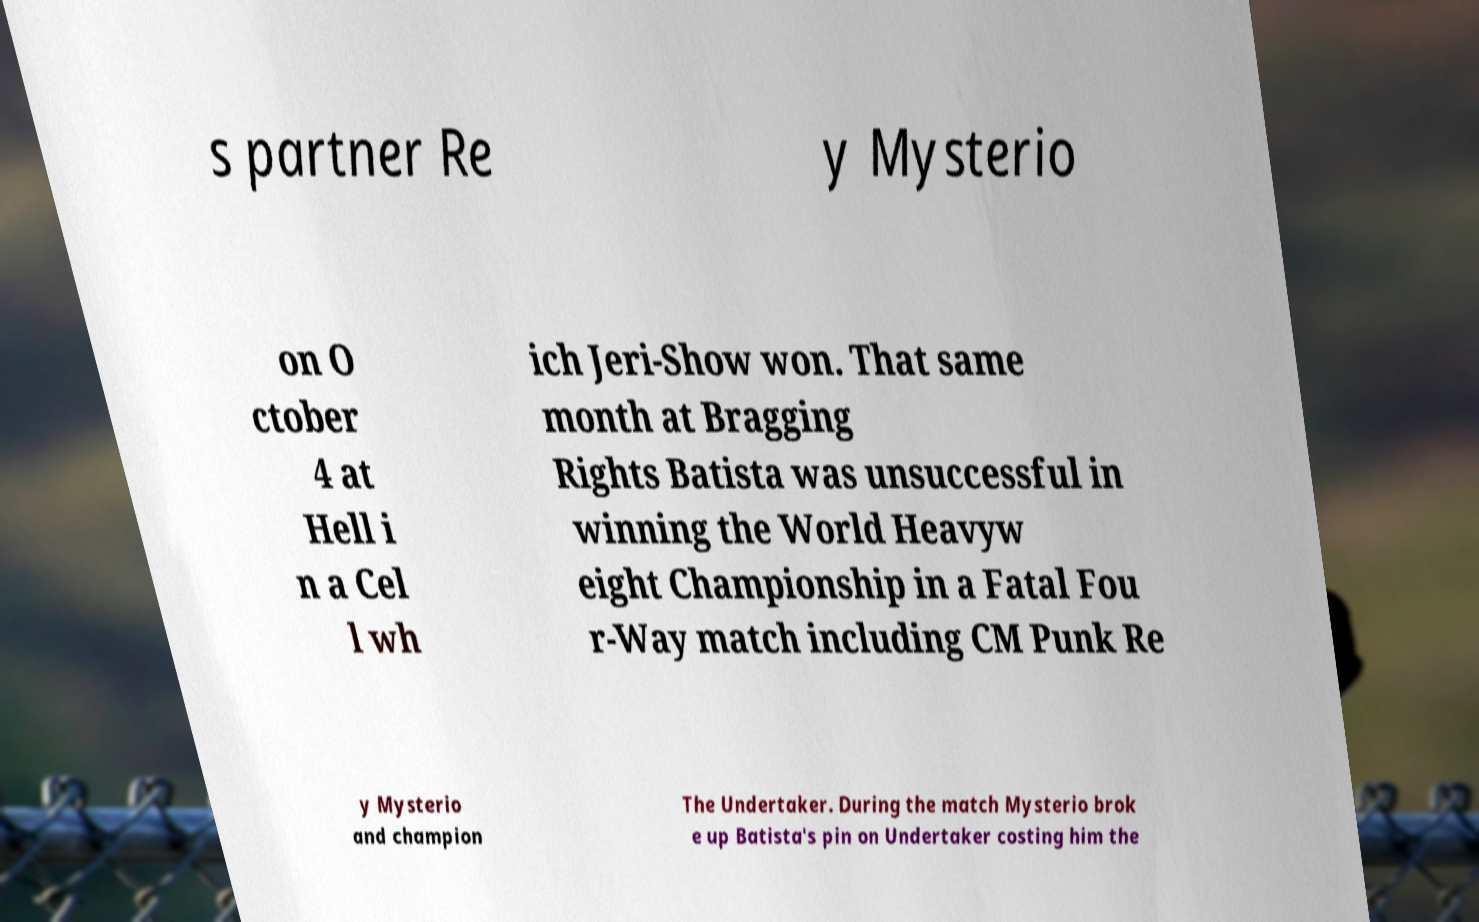Can you read and provide the text displayed in the image?This photo seems to have some interesting text. Can you extract and type it out for me? s partner Re y Mysterio on O ctober 4 at Hell i n a Cel l wh ich Jeri-Show won. That same month at Bragging Rights Batista was unsuccessful in winning the World Heavyw eight Championship in a Fatal Fou r-Way match including CM Punk Re y Mysterio and champion The Undertaker. During the match Mysterio brok e up Batista's pin on Undertaker costing him the 